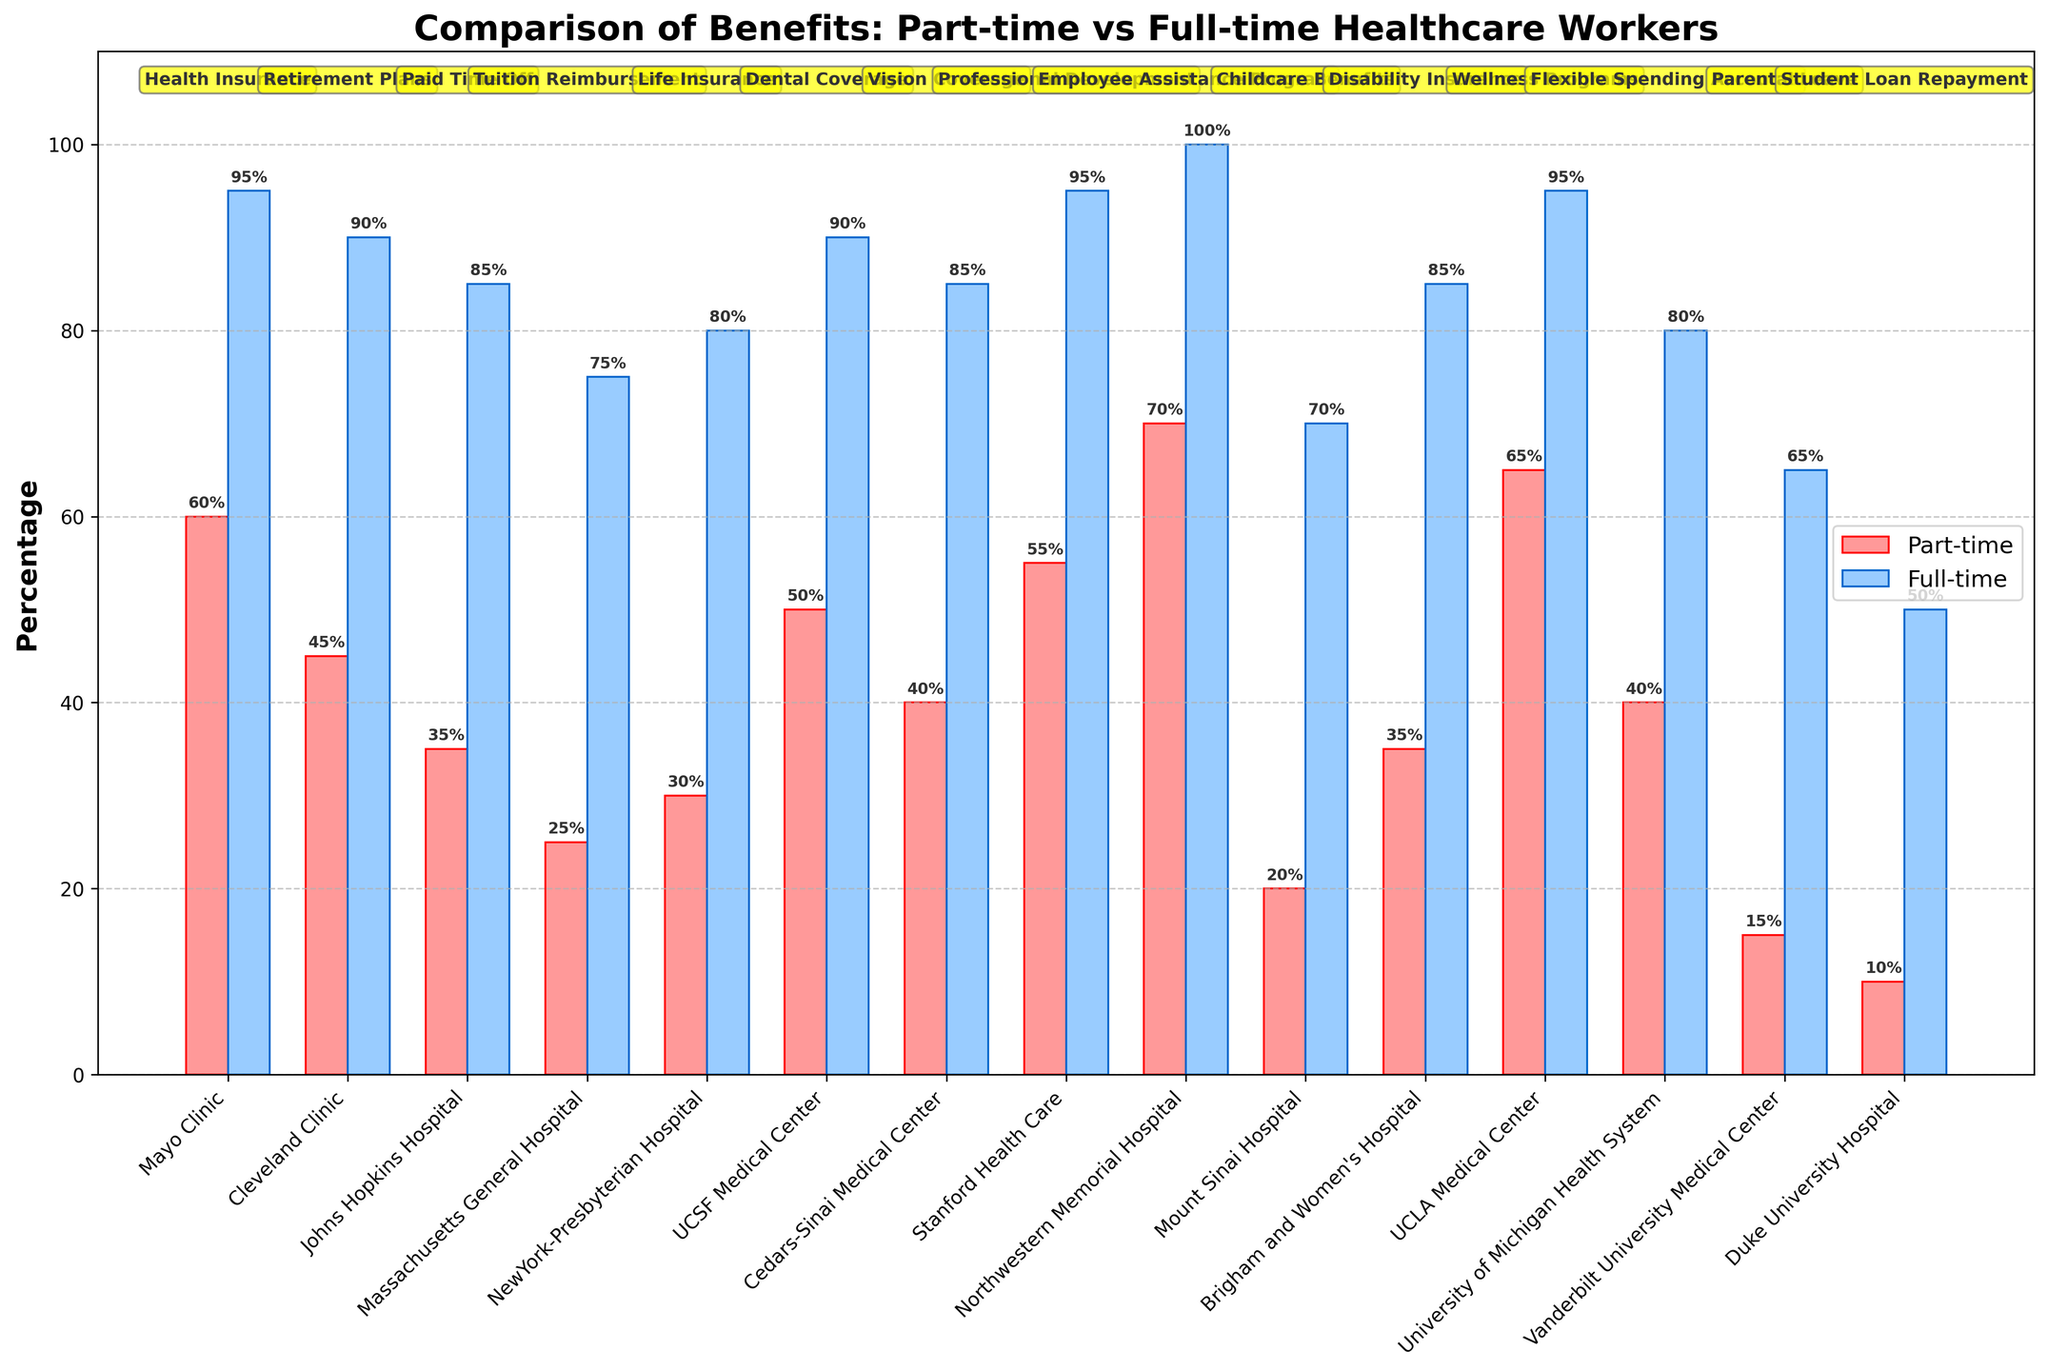Which organization offers the highest percentage of wellness programs to part-time employees? The figure shows the percentages of different benefits provided to part-time employees by various organizations. By scanning the "Wellness Programs" benefits and comparing the heights of the bars, the highest percentage provided to part-time employees is from UCLA Medical Center.
Answer: UCLA Medical Center Which benefit has the smallest percentage difference between part-time and full-time employees at Mayo Clinic? The figure displays the benefits by organization with percentages for part-time and full-time employees. At Mayo Clinic, health insurance is the only benefit shown, with a 35% difference (95% - 60%).
Answer: Health Insurance What is the combined percentage of part-time employees receiving childcare benefits and student loan repayment at Mount Sinai Hospital and Duke University Hospital respectively? The figure has percentages for part-time employees receiving childcare benefits at Mount Sinai Hospital (20%) and student loan repayment at Duke University Hospital (10%). Summing these percentages: 20% + 10% = 30%.
Answer: 30% Which organization shows an equal percentage of part-time and full-time employees receiving a benefit? Observing the figure for any organization where part-time and full-time percentages are the same. Northwestern Memorial Hospital offers an Employee Assistance Program where both part-time and full-time employees receive 100%.
Answer: Northwestern Memorial Hospital How does the part-time percentage for retirement plans at Cleveland Clinic compare to the full-time percentage for tuition reimbursement at Massachusetts General Hospital? The part-time percentage for retirement plans at Cleveland Clinic is 45%, while the full-time percentage for tuition reimbursement at Massachusetts General Hospital is 75%. Comparing these two percentages shows that the part-time percentage is less than the full-time percentage.
Answer: Less than Which benefit is offered to the highest percentage of full-time employees at Johns Hopkins Hospital? By reviewing the benefits at Johns Hopkins Hospital, Paid Time Off is the benefit offered to full-time employees with the highest percentage (85%).
Answer: Paid Time Off What is the average percentage of part-time employees receiving life insurance at NewYork-Presbyterian Hospital and disability insurance at Brigham and Women's Hospital? The figure shows part-time percentages for life insurance at NewYork-Presbyterian Hospital (30%) and disability insurance at Brigham and Women's Hospital (35%). Averaging these: (30% + 35%) / 2 = 32.5%.
Answer: 32.5% What is the visual difference in bar heights for vision coverage between part-time and full-time employees at Cedars-Sinai Medical Center? Looking at the figure, the vision coverage bars at Cedars-Sinai Medical Center are at 40% for part-time and 85% for full-time employees. The visual height difference corresponds to 85% - 40% = 45%.
Answer: 45% Which benefit is least provided to part-time employees at Vanderbilt University Medical Center? Examining the figure, the benefit with the smallest percentage for part-time employees at Vanderbilt University Medical Center is parental leave, with 15%.
Answer: Parental Leave What is the difference in the percentage of part-time employees working at UCSF Medical Center receiving dental coverage compared to those at Stanford Health Care receiving professional development benefits? The figure shows dental coverage percentages for part-time employees at UCSF Medical Center (50%) and professional development benefits at Stanford Health Care (55%). The difference is 55% - 50% = 5%.
Answer: 5% 